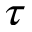<formula> <loc_0><loc_0><loc_500><loc_500>\tau</formula> 